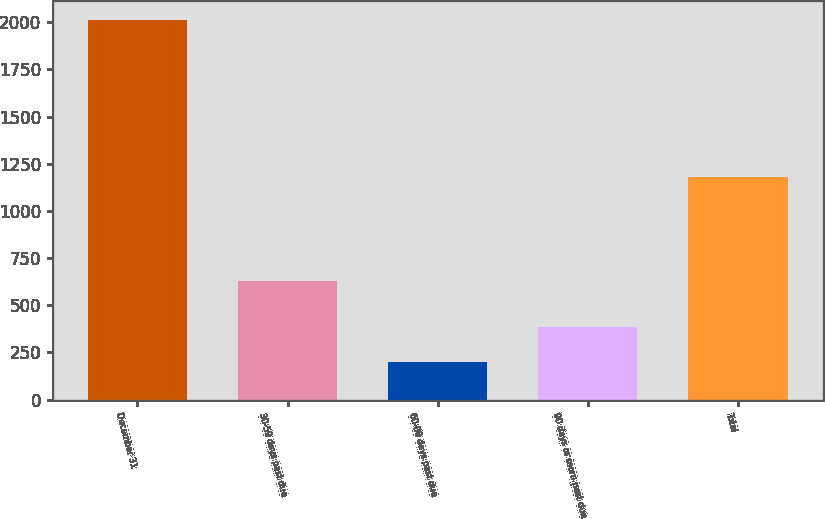Convert chart. <chart><loc_0><loc_0><loc_500><loc_500><bar_chart><fcel>December 31<fcel>30-59 days past due<fcel>60-89 days past due<fcel>90 days or more past due<fcel>Total<nl><fcel>2014<fcel>626<fcel>201<fcel>382.3<fcel>1179<nl></chart> 